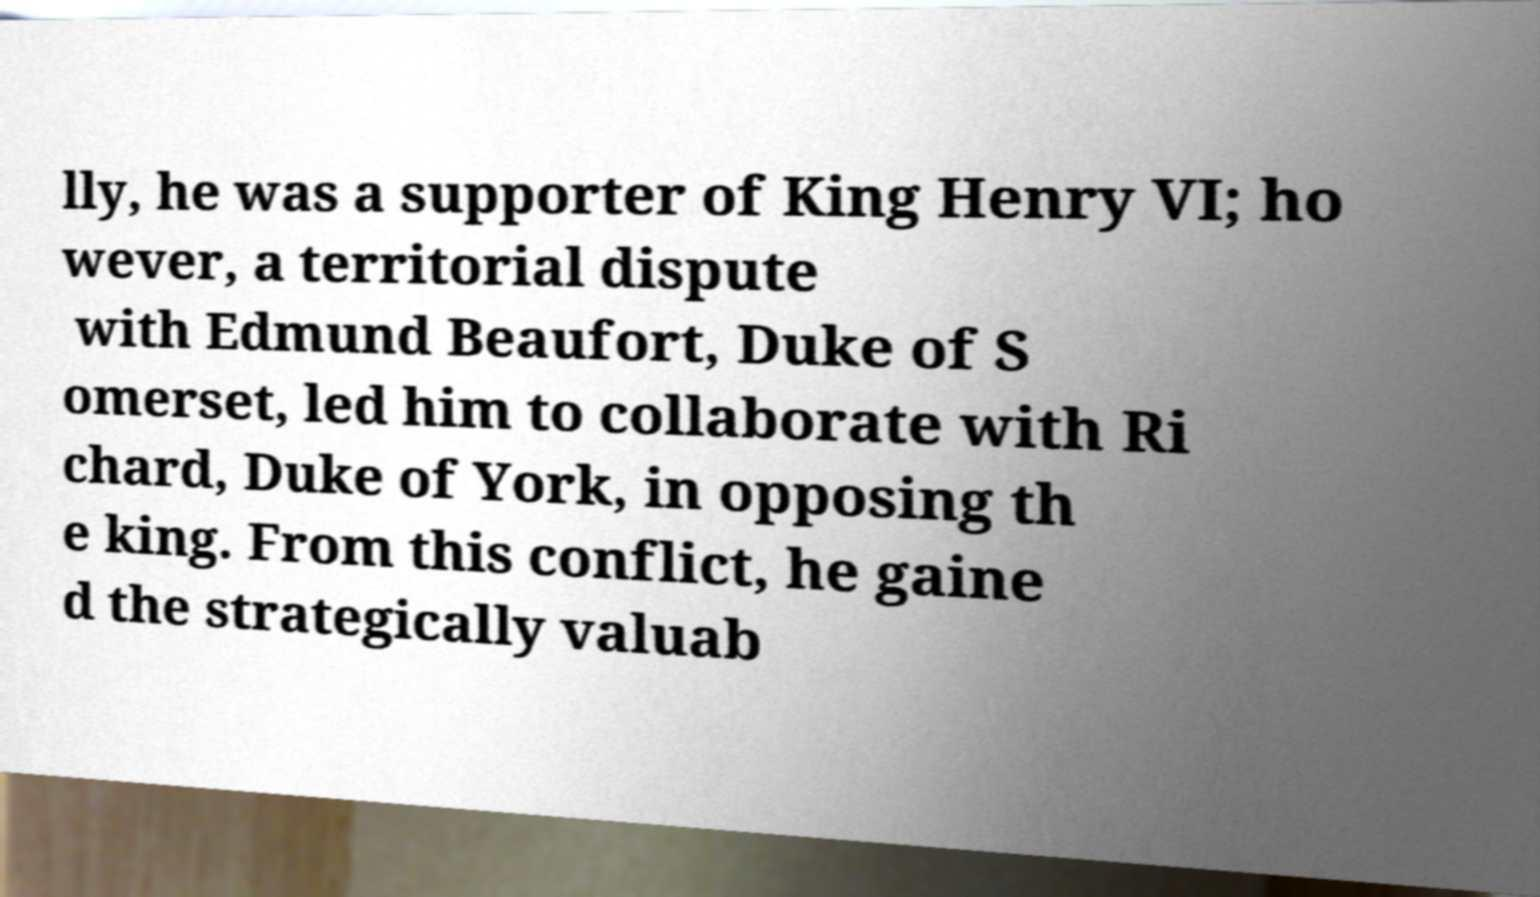I need the written content from this picture converted into text. Can you do that? lly, he was a supporter of King Henry VI; ho wever, a territorial dispute with Edmund Beaufort, Duke of S omerset, led him to collaborate with Ri chard, Duke of York, in opposing th e king. From this conflict, he gaine d the strategically valuab 